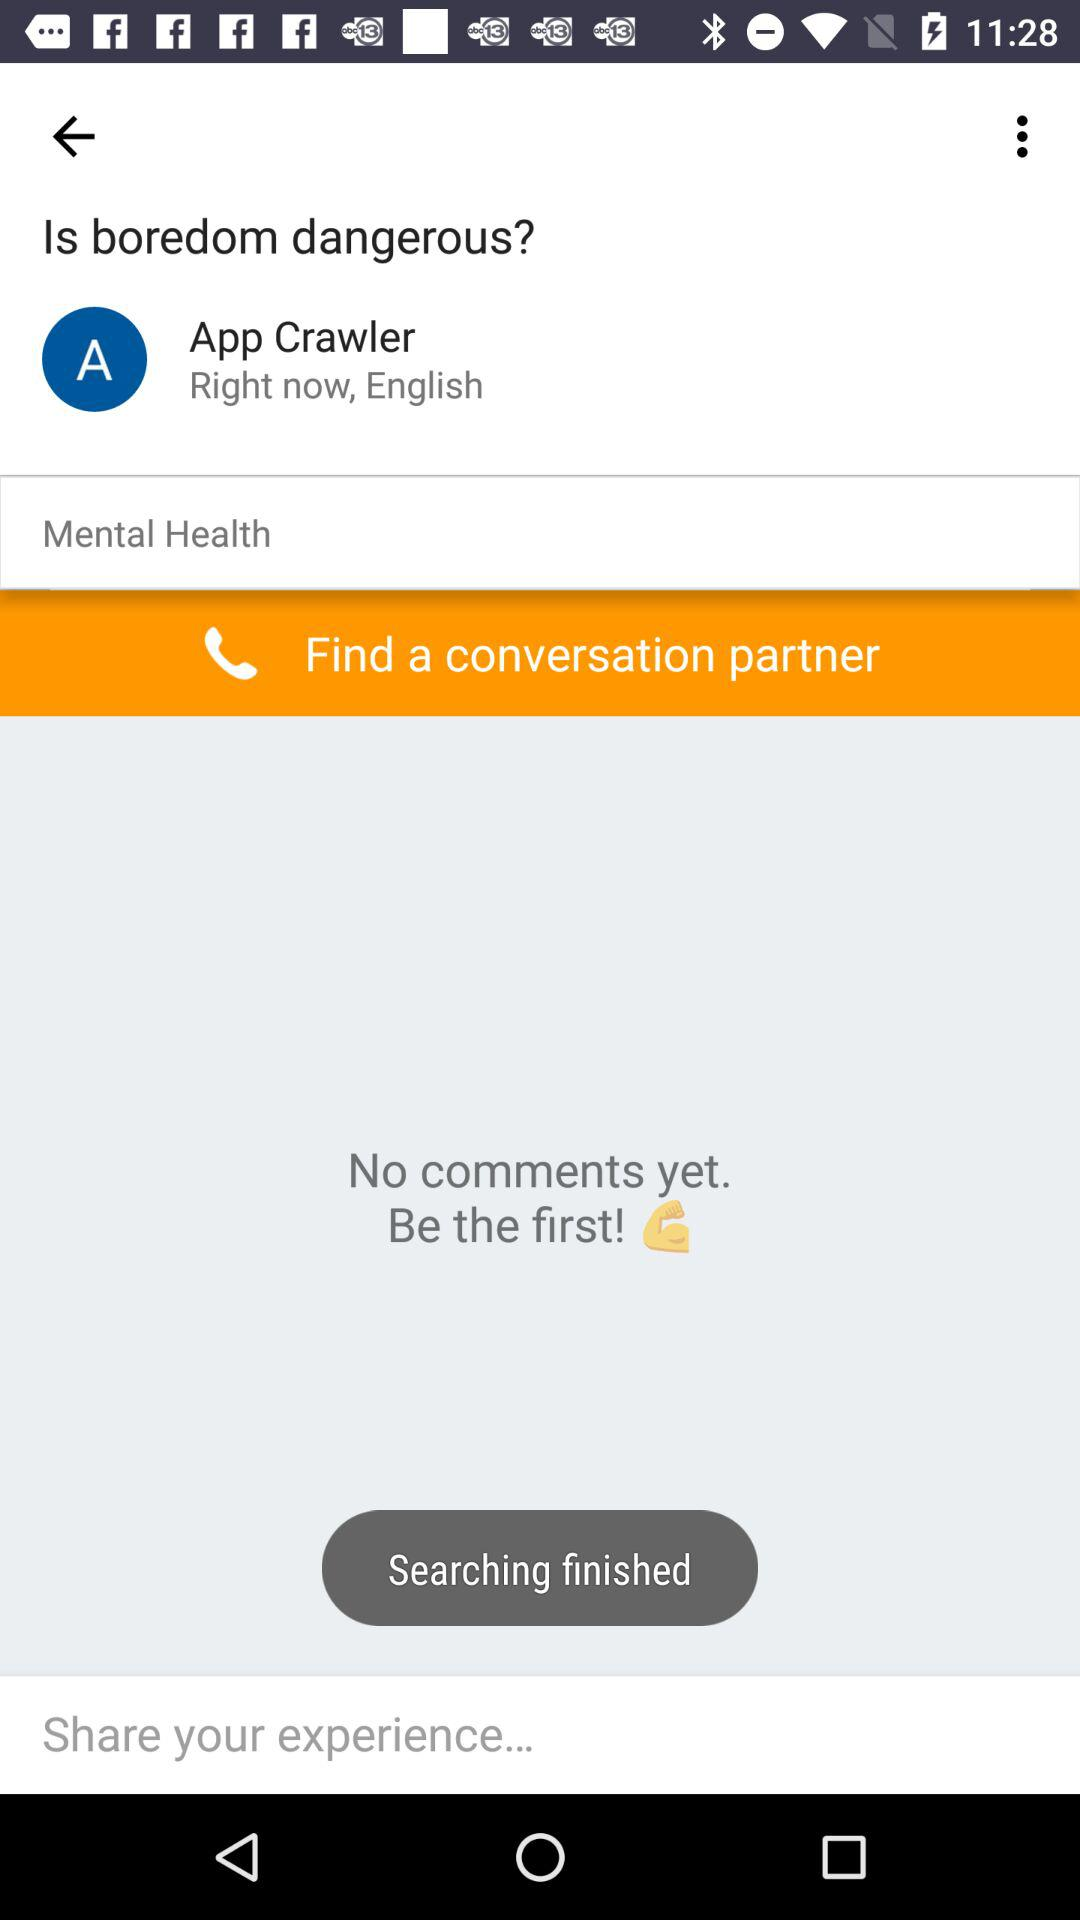What is the mentioned language? The mentioned language is "English". 